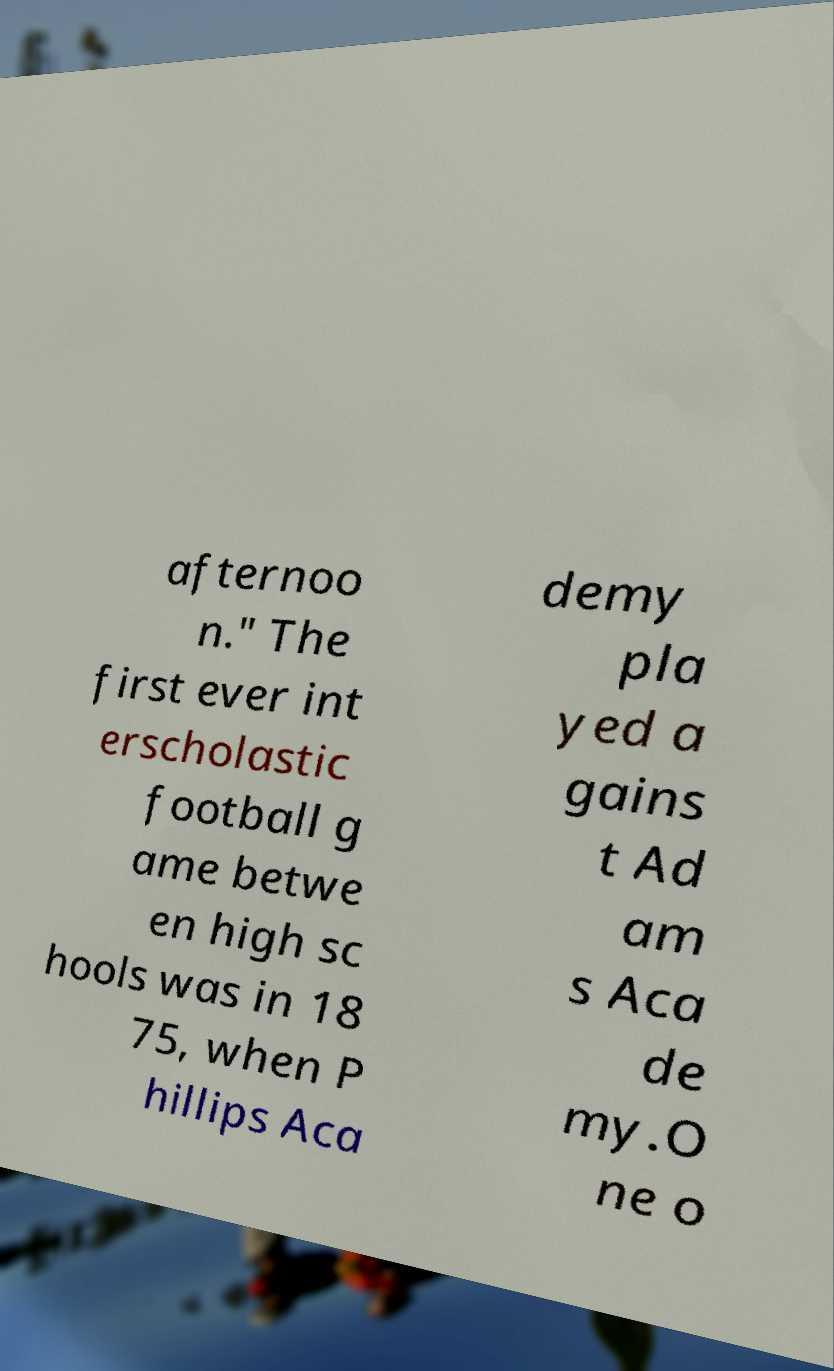For documentation purposes, I need the text within this image transcribed. Could you provide that? afternoo n." The first ever int erscholastic football g ame betwe en high sc hools was in 18 75, when P hillips Aca demy pla yed a gains t Ad am s Aca de my.O ne o 